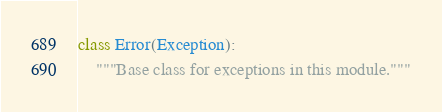Convert code to text. <code><loc_0><loc_0><loc_500><loc_500><_Python_>class Error(Exception):
    """Base class for exceptions in this module."""
</code> 